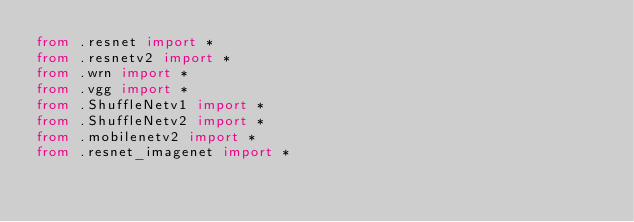<code> <loc_0><loc_0><loc_500><loc_500><_Python_>from .resnet import *
from .resnetv2 import *
from .wrn import *
from .vgg import *
from .ShuffleNetv1 import *
from .ShuffleNetv2 import *
from .mobilenetv2 import *
from .resnet_imagenet import *</code> 